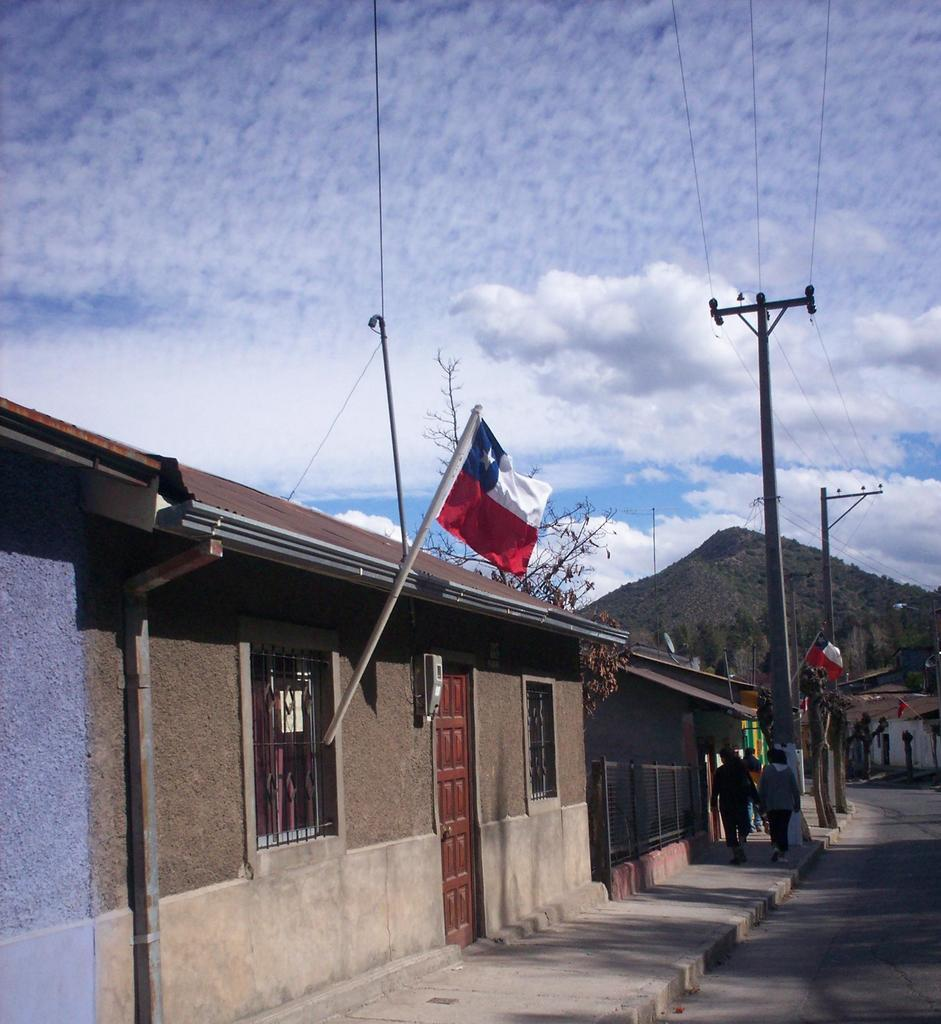What is the weather like in the image? The sky is cloudy in the image. What type of structures can be seen in the image? There are houses in the image. What architectural features are visible on the houses? There are windows and doors visible on the houses. What type of material is present in the image? There is a mesh in the image. What utility object is present in the image? There is a current pole in the image. What symbolic object is present in the image? There is a flag in the image. What type of natural vegetation is present in the image? There are trees in the image. Are there any human figures in the image? Yes, there are people in the image. What type of geographical feature is visible in the distance? There is a mountain visible in the distance. What type of leg can be seen supporting the basket in the image? There is no basket or leg present in the image. 